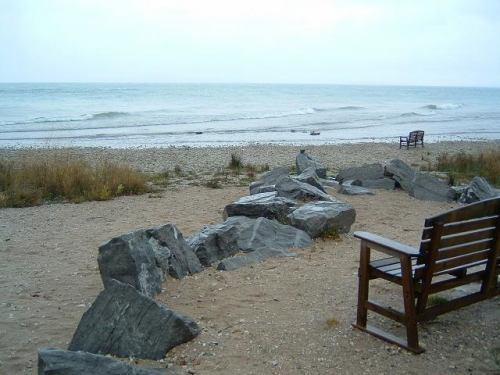How many benches are in the photo?
Give a very brief answer. 2. How many people are in the photo?
Give a very brief answer. 0. 